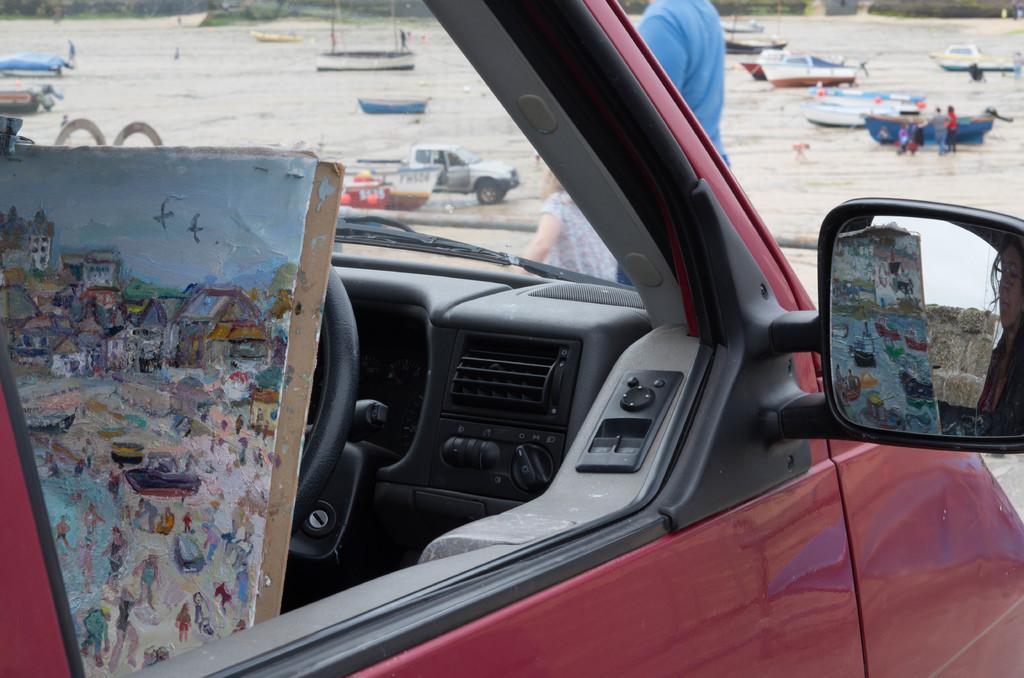How would you summarize this image in a sentence or two? In the image we can see a vehicle. Behind the vehicle two persons are standing. Behind them there is water. Above the water there are some boats and vehicles and few people are there. 